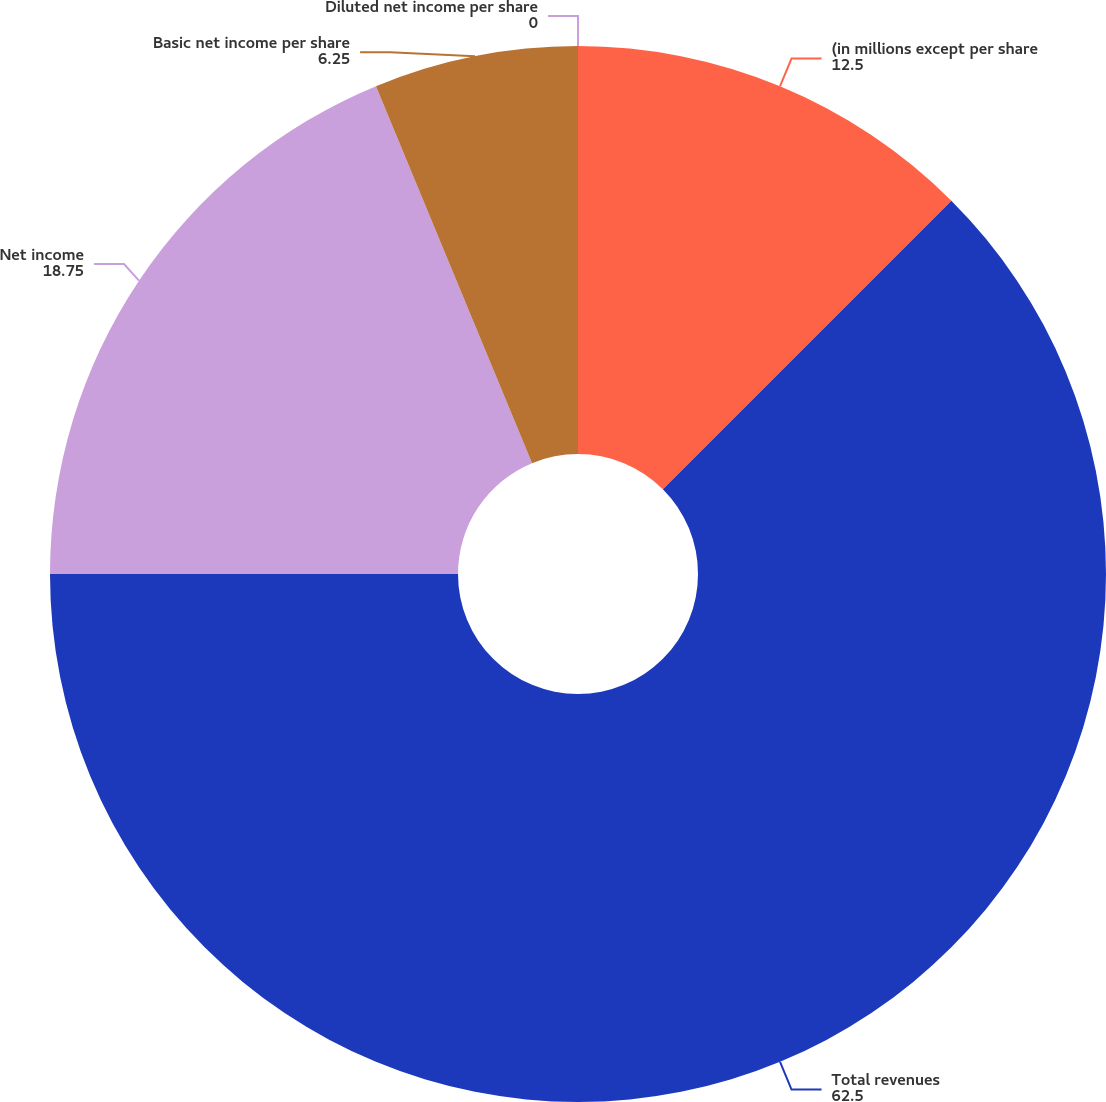Convert chart. <chart><loc_0><loc_0><loc_500><loc_500><pie_chart><fcel>(in millions except per share<fcel>Total revenues<fcel>Net income<fcel>Basic net income per share<fcel>Diluted net income per share<nl><fcel>12.5%<fcel>62.5%<fcel>18.75%<fcel>6.25%<fcel>0.0%<nl></chart> 